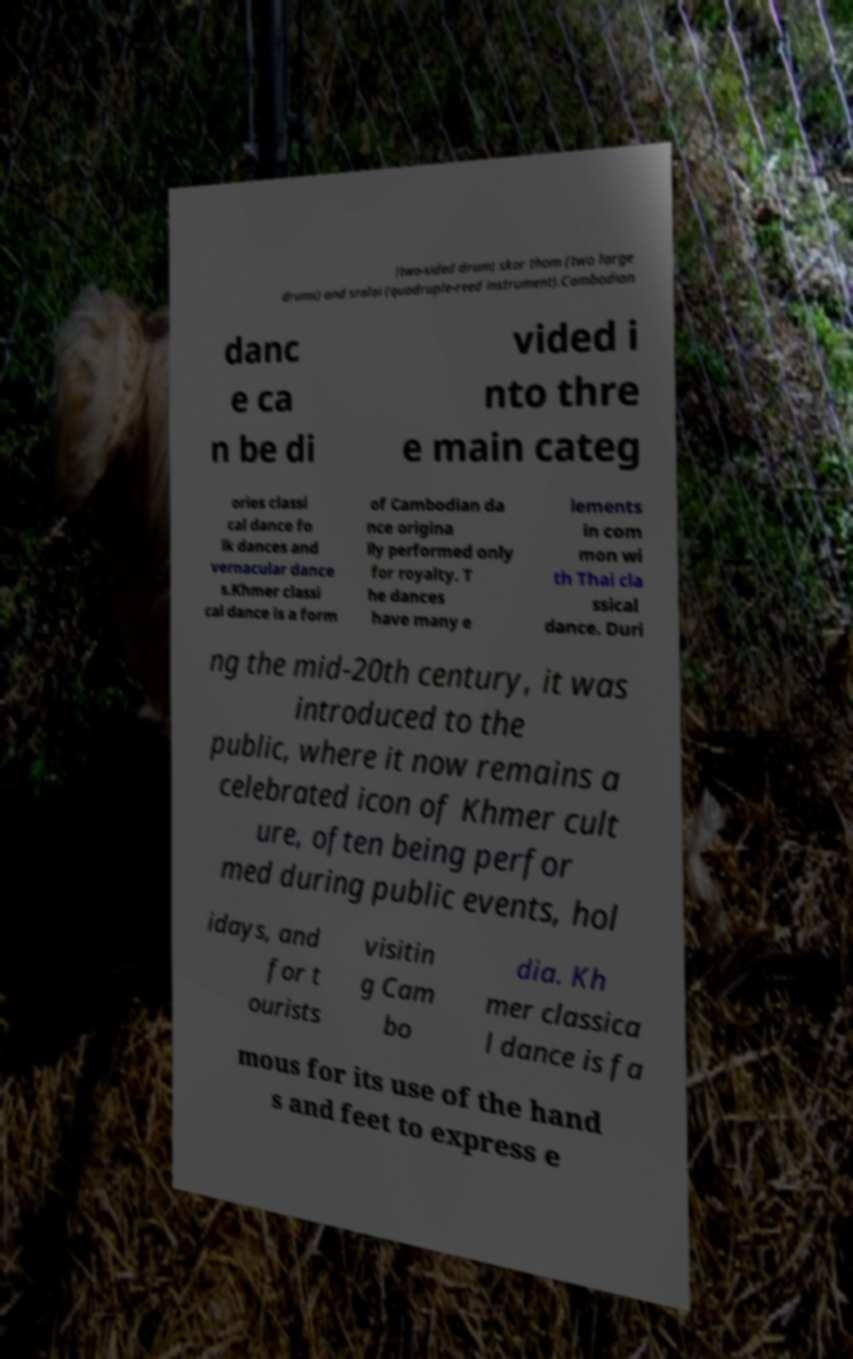I need the written content from this picture converted into text. Can you do that? (two-sided drum) skor thom (two large drums) and sralai (quadruple-reed instrument).Cambodian danc e ca n be di vided i nto thre e main categ ories classi cal dance fo lk dances and vernacular dance s.Khmer classi cal dance is a form of Cambodian da nce origina lly performed only for royalty. T he dances have many e lements in com mon wi th Thai cla ssical dance. Duri ng the mid-20th century, it was introduced to the public, where it now remains a celebrated icon of Khmer cult ure, often being perfor med during public events, hol idays, and for t ourists visitin g Cam bo dia. Kh mer classica l dance is fa mous for its use of the hand s and feet to express e 